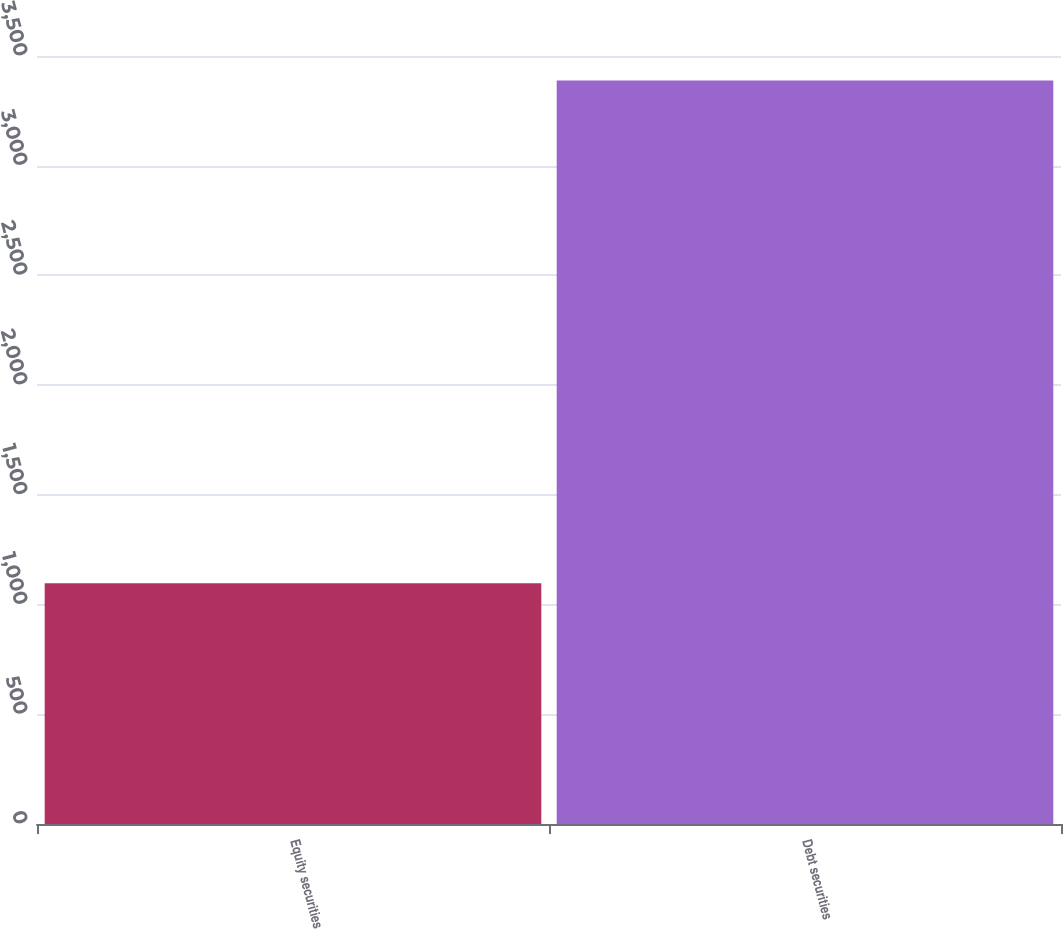Convert chart. <chart><loc_0><loc_0><loc_500><loc_500><bar_chart><fcel>Equity securities<fcel>Debt securities<nl><fcel>1097<fcel>3388<nl></chart> 